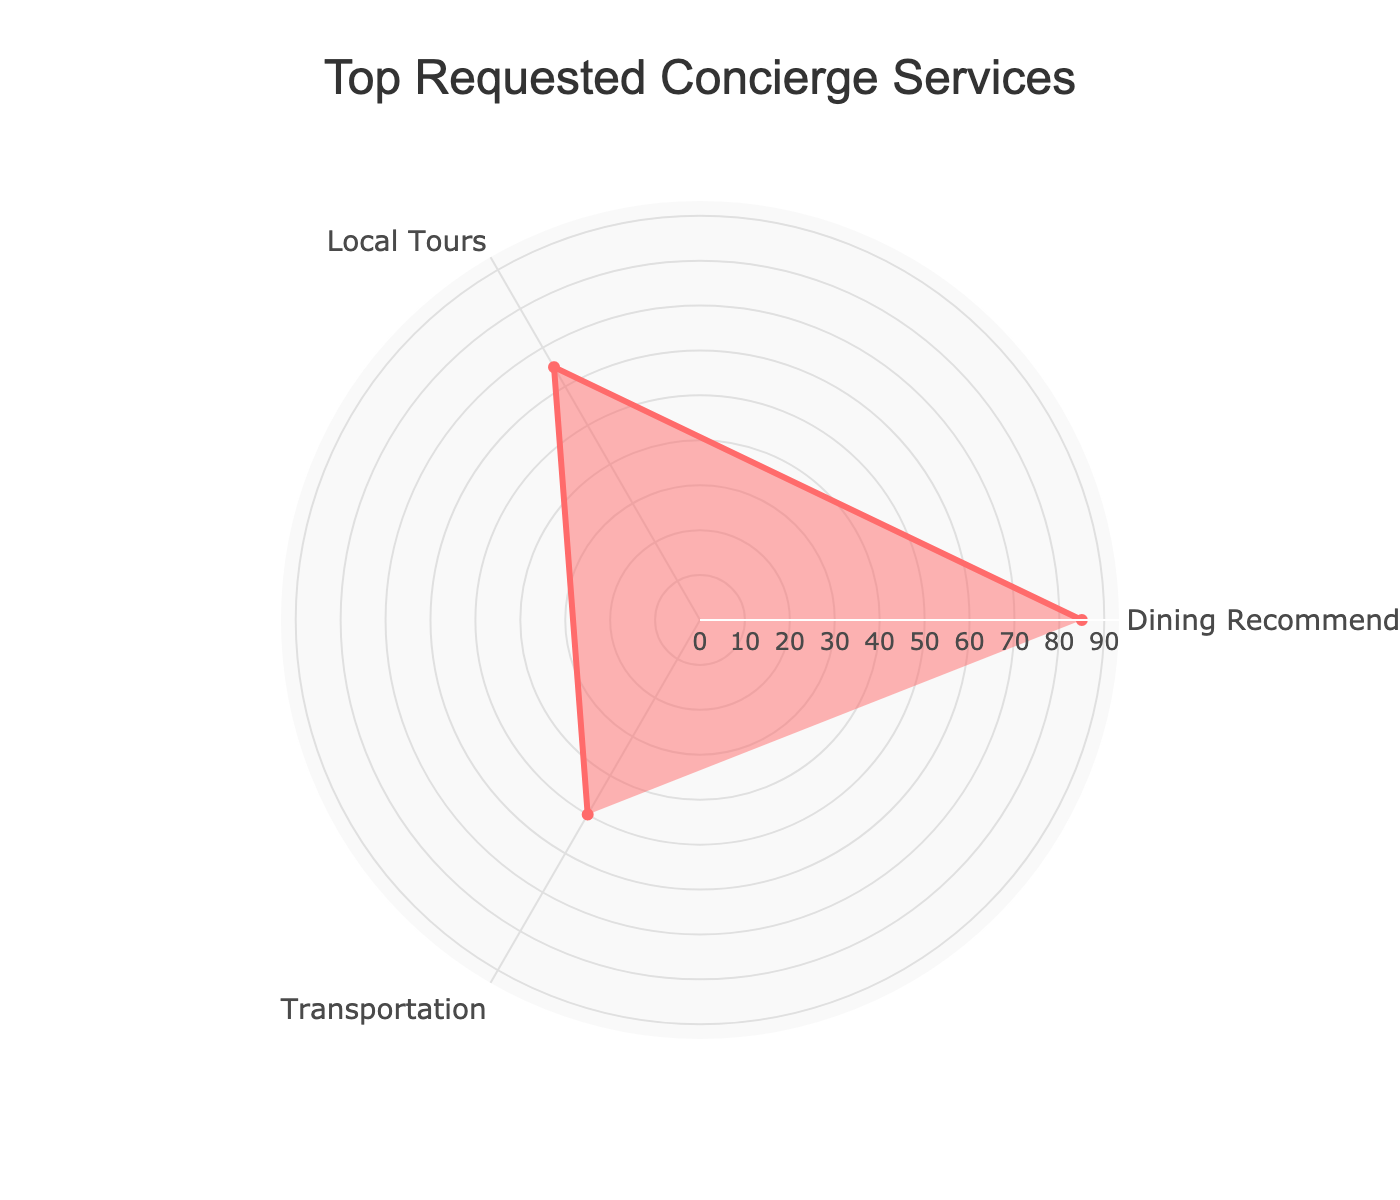What is the title of the radar chart? The title is displayed at the top of the radar chart. It reads "Top Requested Concierge Services".
Answer: Top Requested Concierge Services What are the three services represented in the radar chart? The three services are indicated by the labels along the radar chart axes. They are "Dining Recommendations", "Local Tours", and "Transportation".
Answer: Dining Recommendations, Local Tours, Transportation Which service has the highest frequency of requests? The highest frequency is shown by the longest line extending from the center of the radar chart. This line is toward "Dining Recommendations" at 85.
Answer: Dining Recommendations How many types of services have a frequency of requests of 60 or more? By looking at the chart, the values of "Dining Recommendations" (85) and "Local Tours" (65) are both 60 or more.
Answer: 2 What is the frequency range displayed on the radar chart's radial axis? The maximum value shown on the radial axis is just above the highest frequency, around 95, given that the highest frequency of requests is 85 and there is some space above it.
Answer: 0 to around 95 How much higher is the frequency of Dining Recommendations compared to Transportation? This is calculated by finding the difference between the frequency of Dining Recommendations (85) and Transportation (50). The difference is 85 - 50 = 35.
Answer: 35 What is the average frequency of requests for the three services? The average frequency is calculated by summing the frequencies and dividing by the number of services: (85 + 65 + 50) / 3 = 66.67.
Answer: 66.67 Which service has the lowest frequency of requests? The shortest extension from the center relates to "Transportation" with a frequency of 50.
Answer: Transportation What is the total frequency of requests for all services combined? Adding up all the frequencies: 85 (Dining Recommendations) + 65 (Local Tours) + 50 (Transportation) = 200.
Answer: 200 How does the frequency of Local Tours compare with Transportation? Local Tours have a higher frequency than Transportation. Comparing the values: 65 (Local Tours) is greater than 50 (Transportation).
Answer: Local Tours is higher 